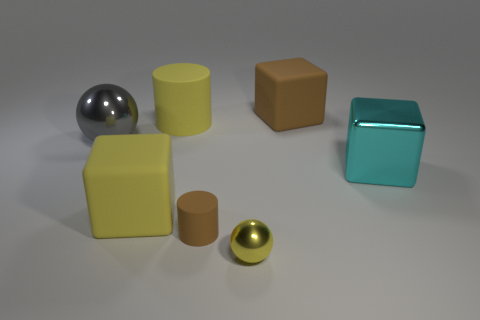What color is the big matte cylinder?
Offer a very short reply. Yellow. There is a brown matte thing that is behind the metal block; what number of rubber cubes are in front of it?
Keep it short and to the point. 1. Is there a large yellow object that is on the left side of the small shiny ball that is to the left of the large cyan metal object?
Your answer should be very brief. Yes. Are there any cyan objects in front of the yellow ball?
Offer a terse response. No. Does the brown thing that is on the right side of the tiny rubber cylinder have the same shape as the tiny yellow metallic thing?
Make the answer very short. No. How many other yellow matte things are the same shape as the tiny yellow thing?
Your answer should be very brief. 0. Are there any gray balls made of the same material as the tiny brown thing?
Offer a very short reply. No. What material is the sphere to the right of the metallic sphere behind the cyan metallic block?
Your response must be concise. Metal. What size is the rubber cube on the right side of the large yellow cylinder?
Your answer should be compact. Large. There is a big metal cube; is its color the same as the big shiny object that is on the left side of the big yellow cylinder?
Provide a short and direct response. No. 